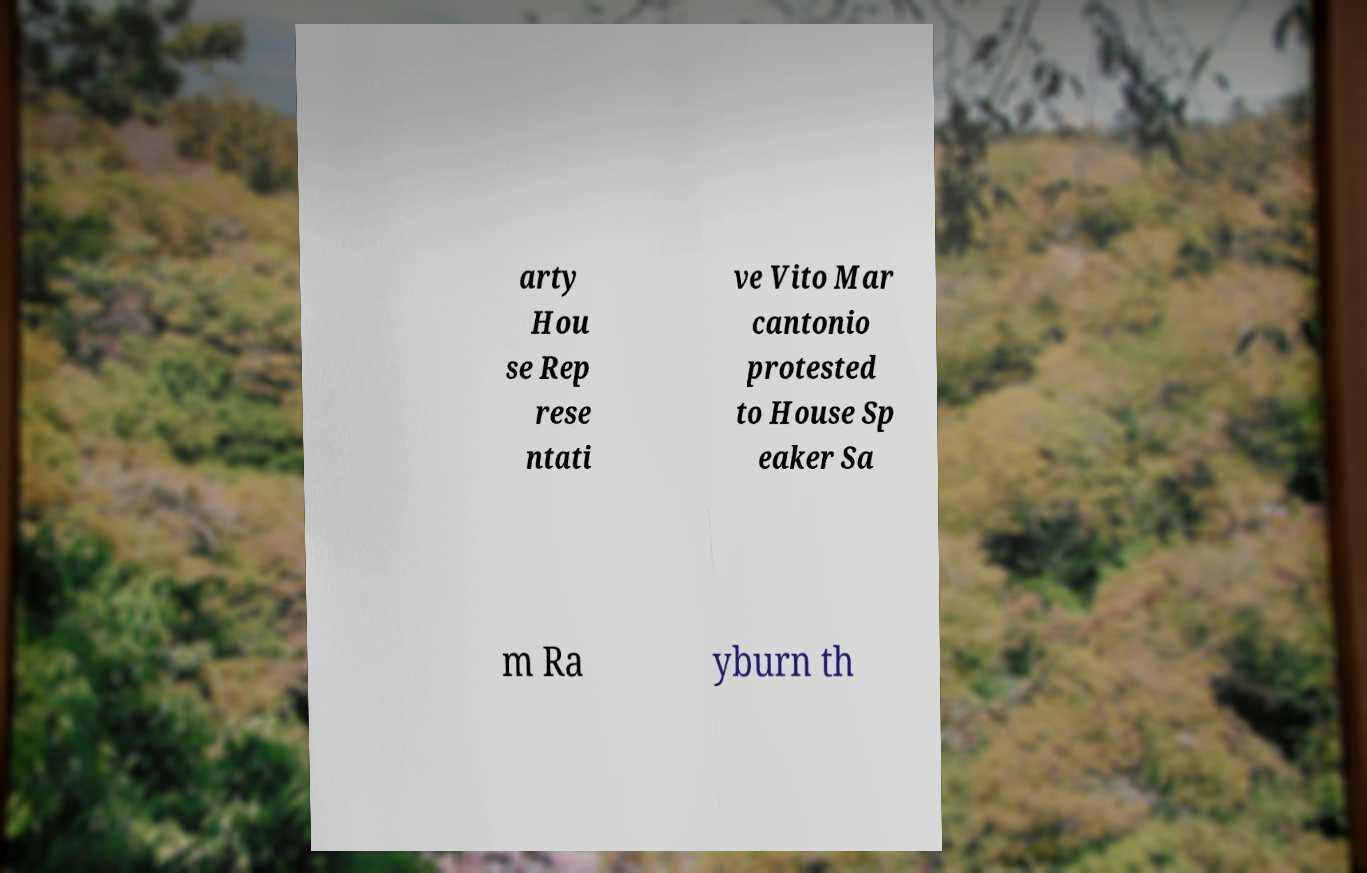I need the written content from this picture converted into text. Can you do that? arty Hou se Rep rese ntati ve Vito Mar cantonio protested to House Sp eaker Sa m Ra yburn th 